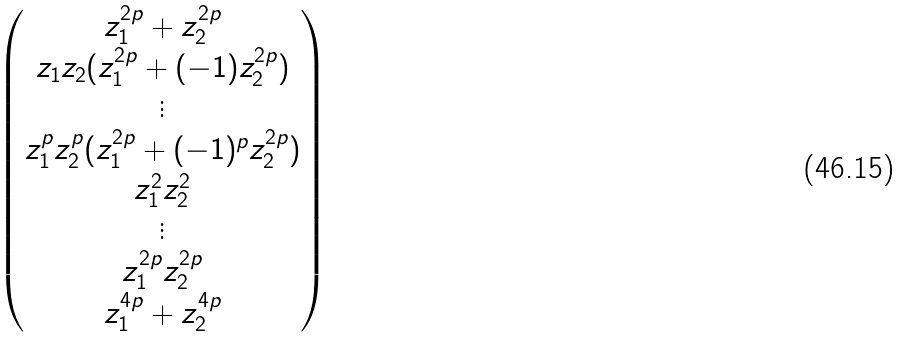Convert formula to latex. <formula><loc_0><loc_0><loc_500><loc_500>\begin{pmatrix} z _ { 1 } ^ { 2 p } + z _ { 2 } ^ { 2 p } \\ z _ { 1 } z _ { 2 } ( z _ { 1 } ^ { 2 p } + ( - 1 ) z _ { 2 } ^ { 2 p } ) \\ \vdots \\ z _ { 1 } ^ { p } z _ { 2 } ^ { p } ( z _ { 1 } ^ { 2 p } + ( - 1 ) ^ { p } z _ { 2 } ^ { 2 p } ) \\ z _ { 1 } ^ { 2 } z _ { 2 } ^ { 2 } \\ \vdots \\ z _ { 1 } ^ { 2 p } z _ { 2 } ^ { 2 p } \\ z _ { 1 } ^ { 4 p } + z _ { 2 } ^ { 4 p } \\ \end{pmatrix}</formula> 